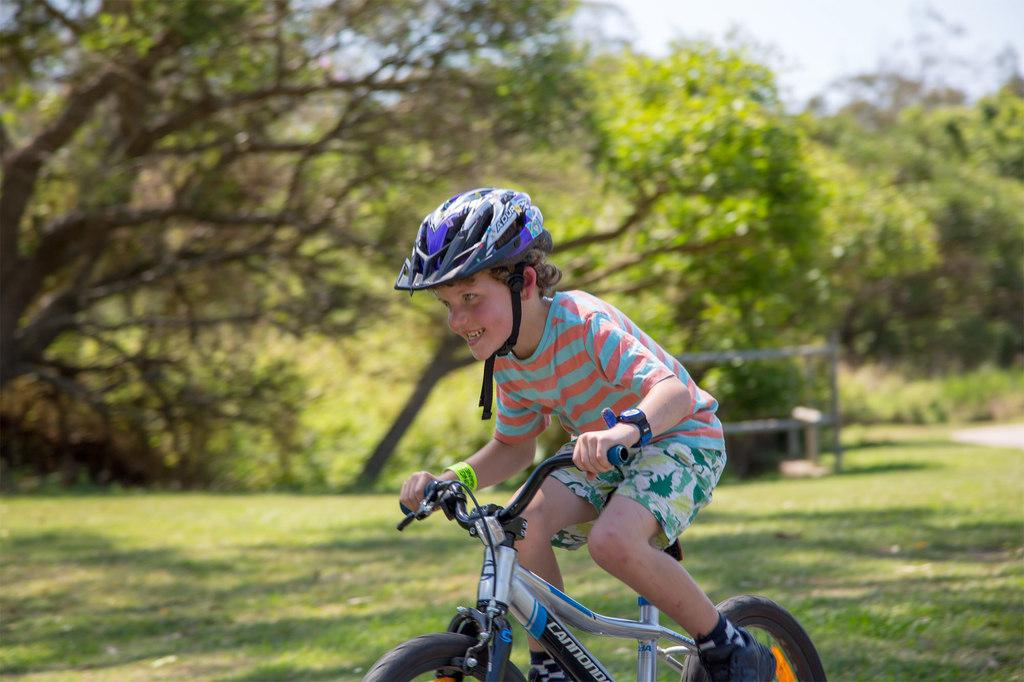Who is the main subject in the image? There is a boy in the image. What is the boy doing in the image? The boy is riding a bicycle. What type of surface is the boy riding on? There is grass on the ground. What type of seating is present in the image? There is a bench in the image. What can be seen in the background of the image? There are trees in the background of the image. What type of needle is the boy using to sew a family portrait in the image? There is no needle or family portrait present in the image; the boy is riding a bicycle. 